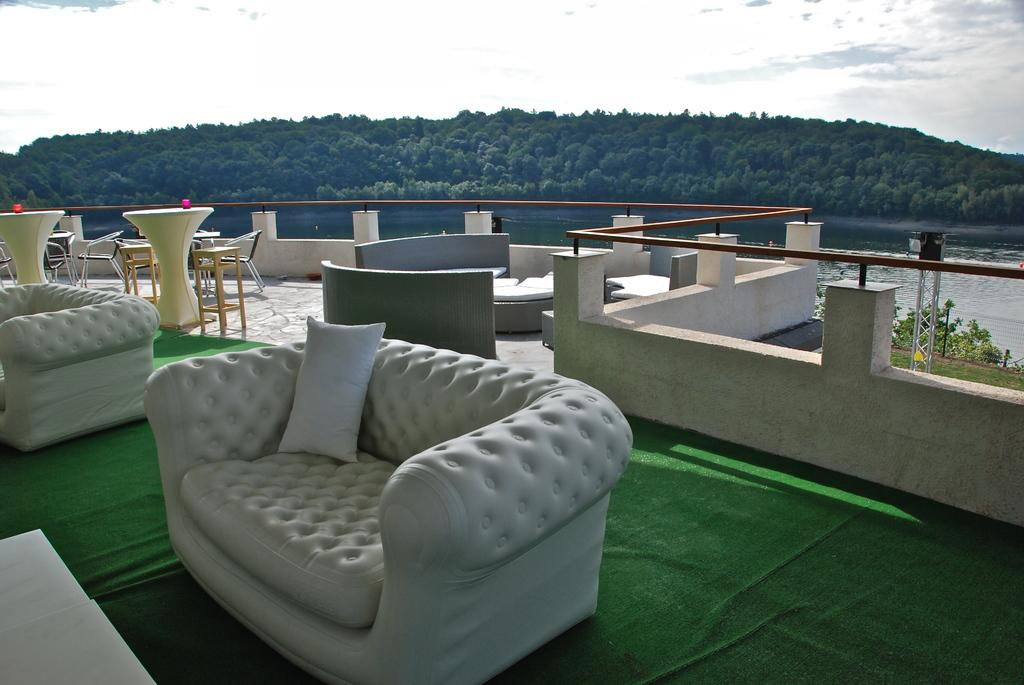How many sofas can be seen in the image? There are many sofas in the image. What is placed on one of the sofas? There is a pillow on one of the sofas. What type of flooring is present in the image? There is a green carpet in the image. What type of furniture can be seen in the background? In the background, there are chairs, tables, sofas, trees, water, and sky. What type of rod is used to hold up the kite in the image? There is no kite present in the image, so there is no rod used to hold it up. 